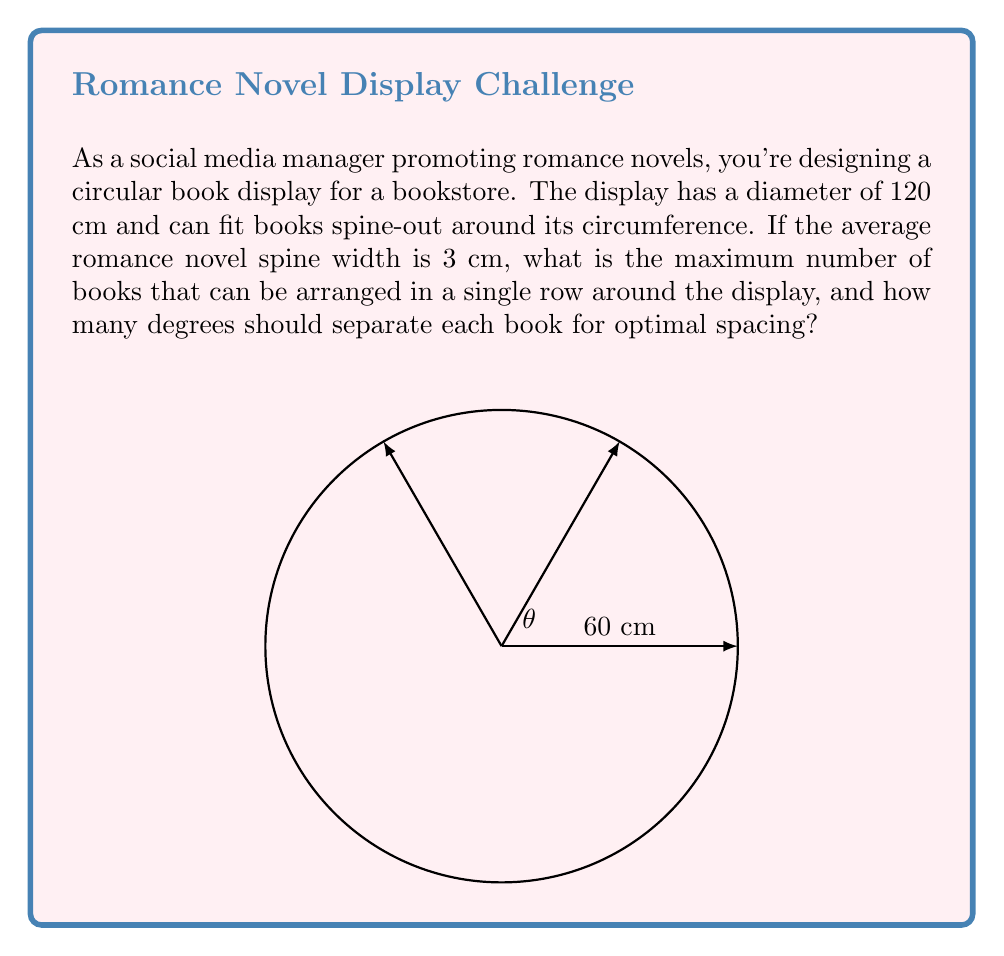Give your solution to this math problem. Let's approach this step-by-step:

1) First, we need to calculate the circumference of the circular display:
   $$C = \pi d = \pi \times 120 \text{ cm} = 376.99 \text{ cm}$$

2) Now, we can determine the maximum number of books that can fit:
   $$\text{Number of books} = \frac{\text{Circumference}}{\text{Book spine width}} = \frac{376.99 \text{ cm}}{3 \text{ cm}} = 125.66$$

   Since we can't have a fractional book, we round down to 125 books.

3) To find the angle between each book, we divide the full circle (360°) by the number of books:
   $$\theta = \frac{360°}{125} = 2.88°$$

4) To verify, we can calculate the arc length each book occupies:
   $$\text{Arc length} = \frac{2.88° \times \pi \times 120 \text{ cm}}{360°} = 3.016 \text{ cm}$$

   This is slightly larger than our book width, which confirms our calculation.

5) For optimal spacing, we should use this angle to ensure equal distribution around the circle.
Answer: 125 books; $2.88°$ between each 